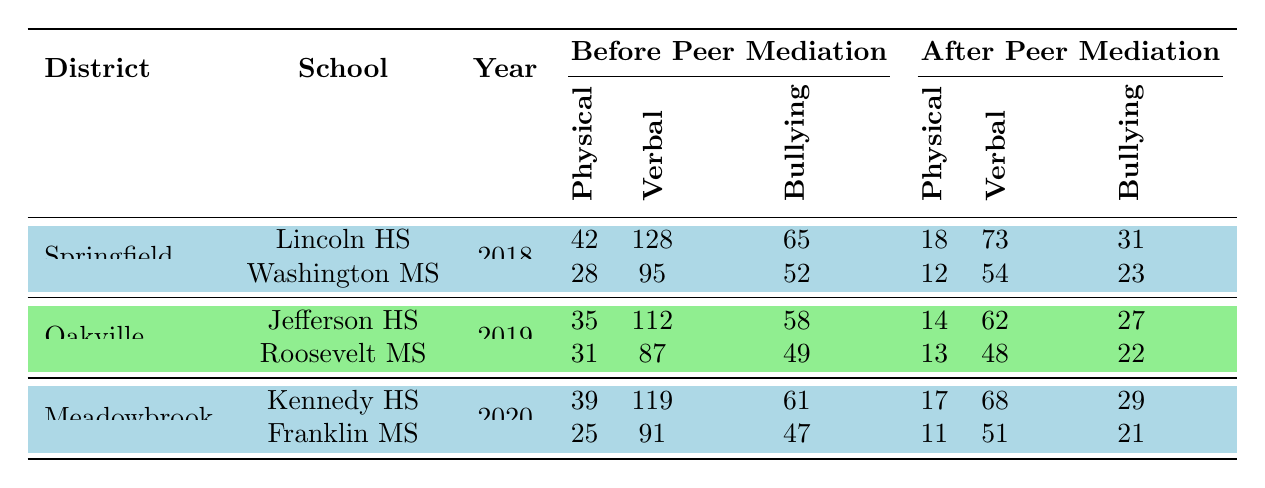What was the total number of physical altercations reported in Lincoln High School before peer mediation? In Lincoln High School, the number of physical altercations before peer mediation is given as 42.
Answer: 42 How many verbal disputes occurred at Washington Middle School after peer mediation? After implementing peer mediation, the number of verbal disputes at Washington Middle School is listed as 54.
Answer: 54 What was the reduction in bullying incidents at Jefferson High School after peer mediation? Before peer mediation, Jefferson High School had 58 bullying incidents, and after peer mediation, it had 27. The reduction can be calculated as 58 - 27 = 31.
Answer: 31 Which school had the highest number of verbal disputes before peer mediation? Comparing the verbal disputes before peer mediation for all schools, Lincoln High School had 128 disputes, which is the highest among all schools.
Answer: Lincoln High School What percentage decrease in physical altercations was observed at Franklin Middle School after peer mediation? Franklin Middle School had 25 physical altercations before peer mediation and 11 after. The decrease is 25 - 11 = 14. The percentage decrease is calculated as (14/25) * 100 = 56%.
Answer: 56% Which school had the highest reduction in suspensions after peer mediation, and what was the number? By analyzing the suspensions before and after for each school: Lincoln HS (48), Washington MS (32), Jefferson HS (41), Roosevelt MS (32), Kennedy HS (44), Franklin MS (30). The highest reduction occurred at Lincoln High School with a reduction of 48 suspensions (before) to 41 (after), a difference of 48 - 41 = 7.
Answer: Lincoln High School, 7 After peer mediation, did Roosevelt Middle School report more physical altercations than before? Roosevelt Middle School had 31 physical altercations before peer mediation and 13 after. Since 13 is less than 31, it did not report more after peer mediation.
Answer: No What is the average number of bullying incidents before peer mediation across all schools? The total number of bullying incidents before peer mediation is 65 (Lincoln) + 52 (Washington) + 58 (Jefferson) + 49 (Roosevelt) + 61 (Kennedy) + 47 (Franklin) = 332. There are 6 schools, so the average is 332/6 = 55.33.
Answer: 55.33 Did the district that implemented peer mediation in 2019 have a higher number of verbal disputes before than the district that implemented it in 2018? Oakville School District (2019) had 112 (Jefferson) + 87 (Roosevelt) = 199 verbal disputes before peer mediation, and Springfield Unified (2018) had 128 (Lincoln) + 95 (Washington) = 223 disputes. Since 199 is less than 223, the 2019's district had fewer disputes.
Answer: No Which school saw the least change in the number of suspensions after peer mediation? By examining the suspensions before and after mediation: Lincoln HS (48 to 41), Washington MS (61 to 29), Jefferson HS (76 to 35), Roosevelt MS (58 to 26), Kennedy HS (82 to 38), and Franklin MS (55 to 25). Franklin Middle School had the least reduction of 30 suspensions.
Answer: Franklin Middle School 